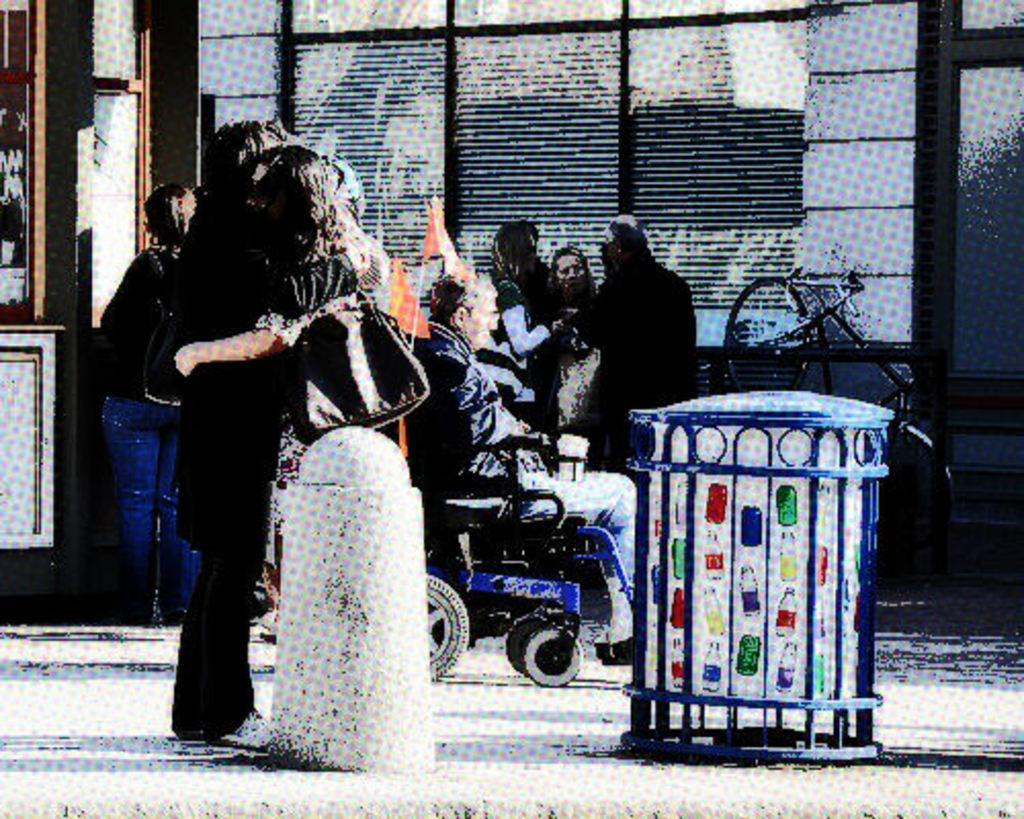What is happening in the middle of the image? There are people standing in the middle of the image. Can you describe the person in a different position? There is a person sitting on a wheelchair. What can be seen in the background of the image? There is a wall in the background of the image. Where is the kitten playing in the field in the image? There is no kitten or field present in the image. How does the water flow around the people in the image? There is no water present in the image. 